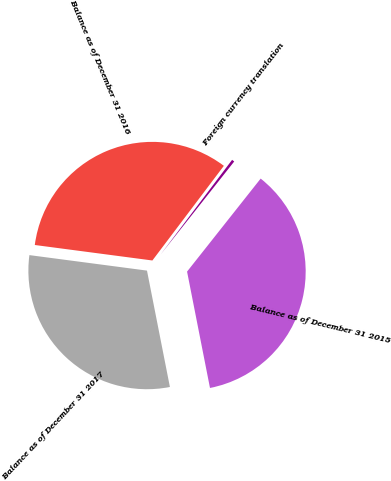Convert chart. <chart><loc_0><loc_0><loc_500><loc_500><pie_chart><fcel>Balance as of December 31 2015<fcel>Foreign currency translation<fcel>Balance as of December 31 2016<fcel>Balance as of December 31 2017<nl><fcel>36.25%<fcel>0.36%<fcel>33.21%<fcel>30.18%<nl></chart> 